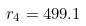Convert formula to latex. <formula><loc_0><loc_0><loc_500><loc_500>r _ { 4 } = 4 9 9 . 1</formula> 